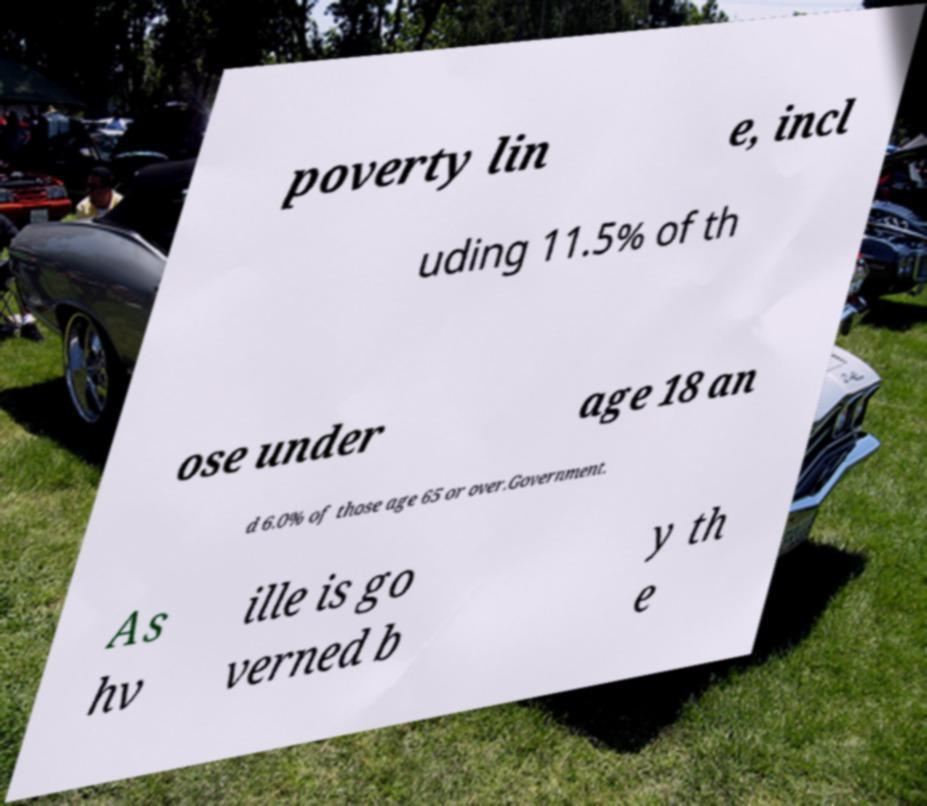Please read and relay the text visible in this image. What does it say? poverty lin e, incl uding 11.5% of th ose under age 18 an d 6.0% of those age 65 or over.Government. As hv ille is go verned b y th e 